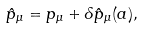Convert formula to latex. <formula><loc_0><loc_0><loc_500><loc_500>\hat { p } _ { \mu } = p _ { \mu } + \delta \hat { p } _ { \mu } ( a ) ,</formula> 